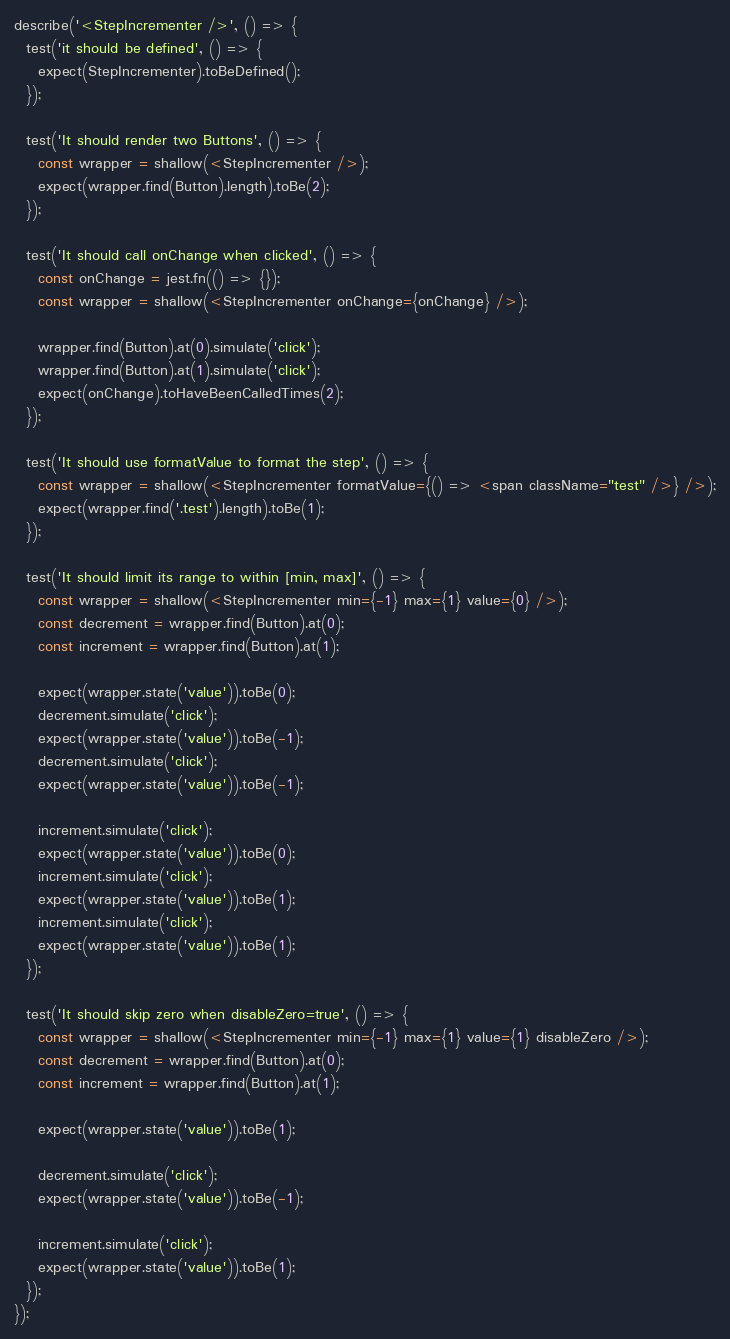Convert code to text. <code><loc_0><loc_0><loc_500><loc_500><_JavaScript_>
describe('<StepIncrementer />', () => {
  test('it should be defined', () => {
    expect(StepIncrementer).toBeDefined();
  });

  test('It should render two Buttons', () => {
    const wrapper = shallow(<StepIncrementer />);
    expect(wrapper.find(Button).length).toBe(2);
  });

  test('It should call onChange when clicked', () => {
    const onChange = jest.fn(() => {});
    const wrapper = shallow(<StepIncrementer onChange={onChange} />);

    wrapper.find(Button).at(0).simulate('click');
    wrapper.find(Button).at(1).simulate('click');
    expect(onChange).toHaveBeenCalledTimes(2);
  });

  test('It should use formatValue to format the step', () => {
    const wrapper = shallow(<StepIncrementer formatValue={() => <span className="test" />} />);
    expect(wrapper.find('.test').length).toBe(1);
  });

  test('It should limit its range to within [min, max]', () => {
    const wrapper = shallow(<StepIncrementer min={-1} max={1} value={0} />);
    const decrement = wrapper.find(Button).at(0);
    const increment = wrapper.find(Button).at(1);

    expect(wrapper.state('value')).toBe(0);
    decrement.simulate('click');
    expect(wrapper.state('value')).toBe(-1);
    decrement.simulate('click');
    expect(wrapper.state('value')).toBe(-1);

    increment.simulate('click');
    expect(wrapper.state('value')).toBe(0);
    increment.simulate('click');
    expect(wrapper.state('value')).toBe(1);
    increment.simulate('click');
    expect(wrapper.state('value')).toBe(1);
  });

  test('It should skip zero when disableZero=true', () => {
    const wrapper = shallow(<StepIncrementer min={-1} max={1} value={1} disableZero />);
    const decrement = wrapper.find(Button).at(0);
    const increment = wrapper.find(Button).at(1);

    expect(wrapper.state('value')).toBe(1);

    decrement.simulate('click');
    expect(wrapper.state('value')).toBe(-1);

    increment.simulate('click');
    expect(wrapper.state('value')).toBe(1);
  });
});
</code> 